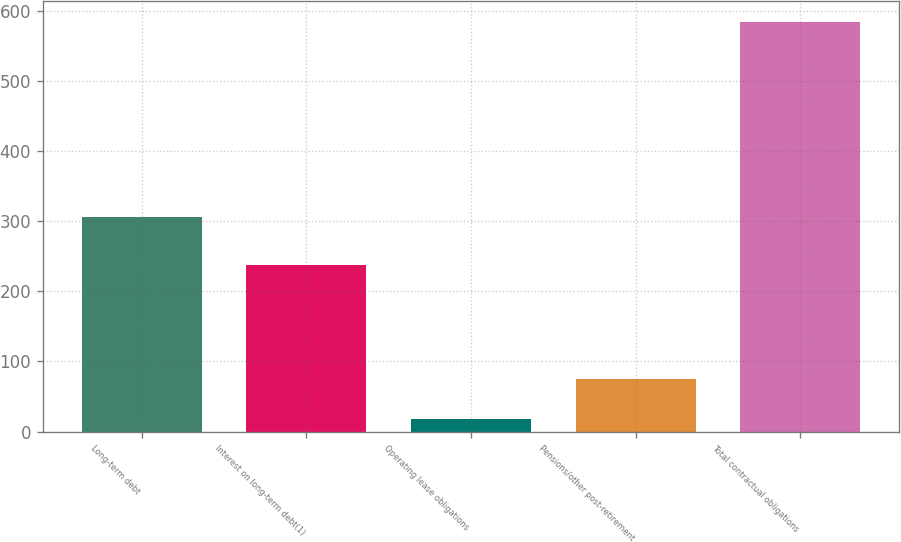<chart> <loc_0><loc_0><loc_500><loc_500><bar_chart><fcel>Long-term debt<fcel>Interest on long-term debt(1)<fcel>Operating lease obligations<fcel>Pensions/other post-retirement<fcel>Total contractual obligations<nl><fcel>306.5<fcel>237.2<fcel>18.2<fcel>74.82<fcel>584.4<nl></chart> 